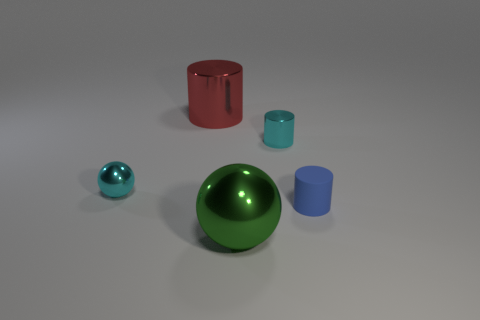Are there any big red cylinders to the right of the tiny cyan shiny object on the left side of the green shiny sphere?
Make the answer very short. Yes. Is the size of the red thing the same as the ball that is left of the large red shiny cylinder?
Give a very brief answer. No. Are there any cyan shiny things left of the cyan cylinder to the left of the tiny thing that is on the right side of the small cyan metal cylinder?
Provide a short and direct response. Yes. There is a big thing that is behind the big green metal object; what material is it?
Ensure brevity in your answer.  Metal. Is the cyan cylinder the same size as the red metal cylinder?
Provide a succinct answer. No. There is a metallic thing that is both on the left side of the small metallic cylinder and right of the red thing; what is its color?
Give a very brief answer. Green. There is a big red thing that is made of the same material as the green object; what is its shape?
Your answer should be very brief. Cylinder. How many objects are both to the right of the cyan metal cylinder and in front of the tiny rubber object?
Make the answer very short. 0. Are there any shiny cylinders on the left side of the green object?
Provide a short and direct response. Yes. Is the shape of the small cyan shiny thing behind the tiny sphere the same as the large thing that is behind the tiny metal ball?
Your answer should be very brief. Yes. 